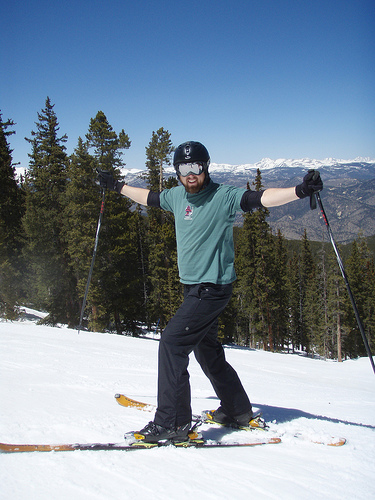<image>
Can you confirm if the man is behind the tree? No. The man is not behind the tree. From this viewpoint, the man appears to be positioned elsewhere in the scene. 